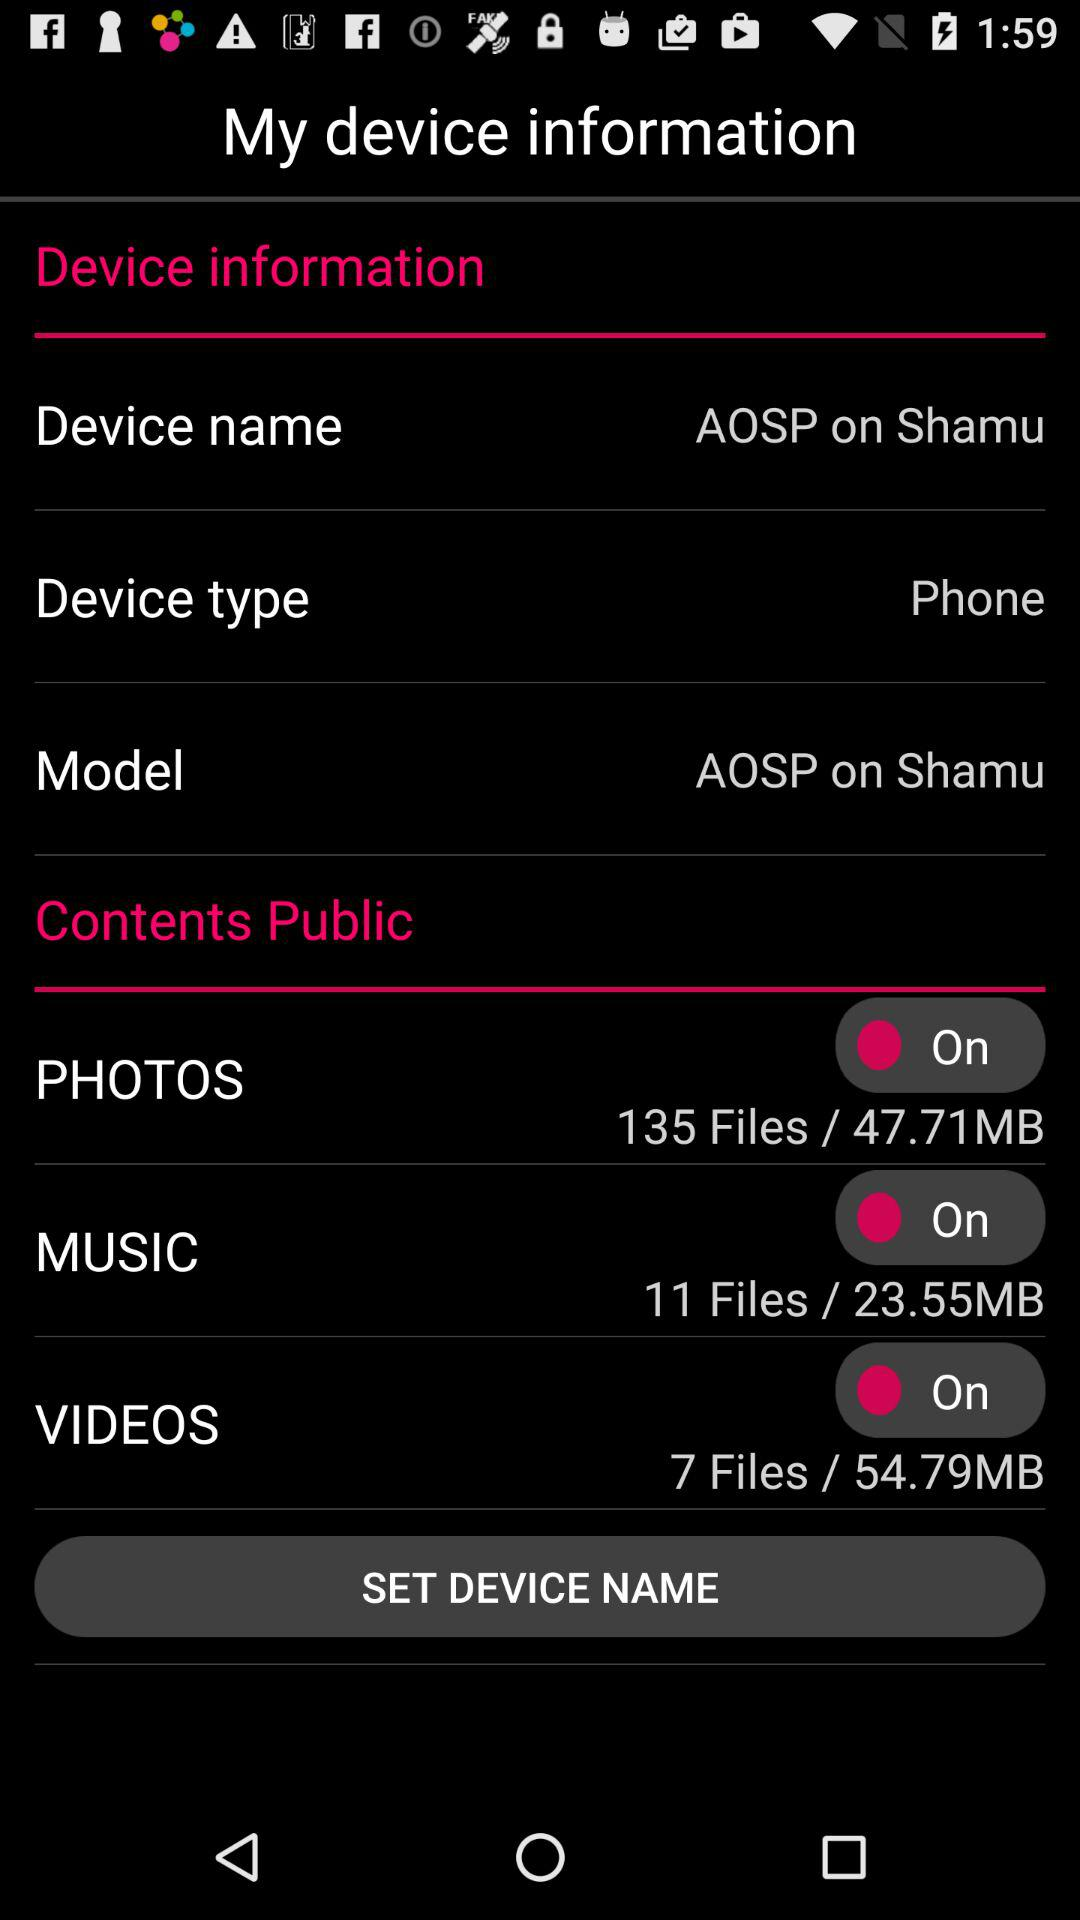What is the name of this device? It is "AOSP on Shamu". 